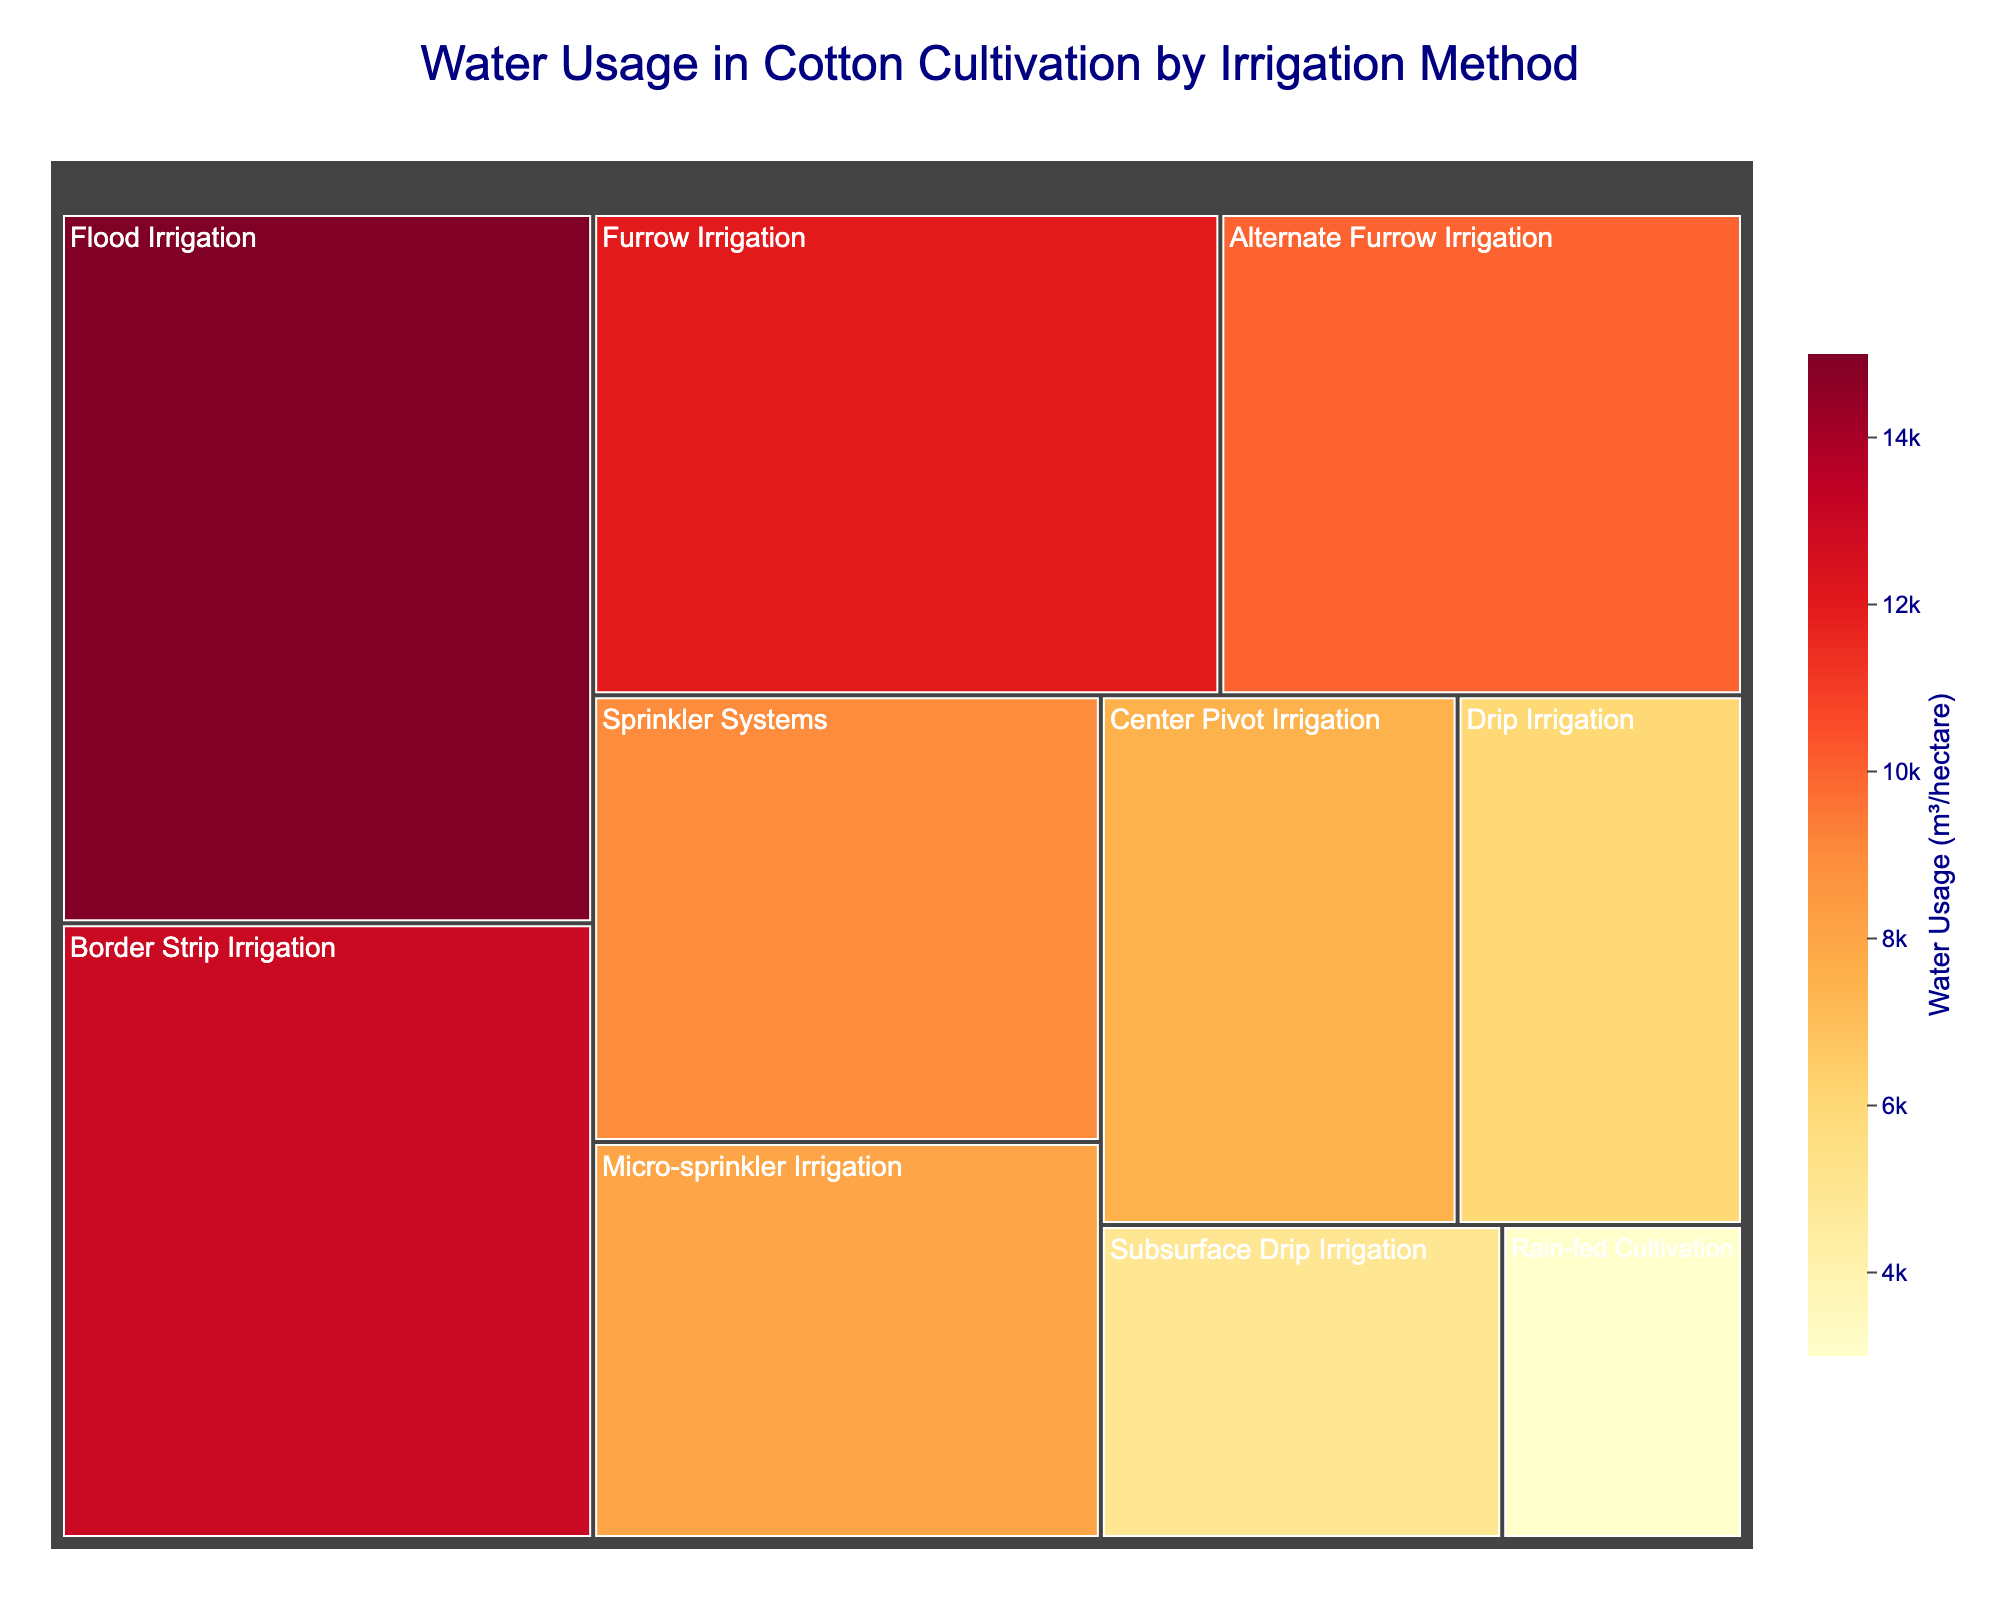Which irrigation method has the highest water usage? The figure allows us to see that the Flood Irrigation method has the largest area and darkest color, indicating the highest water usage.
Answer: Flood Irrigation What is the water usage for Drip Irrigation? By referring to the size and label of the Drip Irrigation section, which is smaller and lighter than others, the water usage is shown as 6000 m³/hectare.
Answer: 6000 m³/hectare How many irrigation methods use more than 10000 m³/hectare of water? Checking the sections with water usage values on the treemap, Flood Irrigation (15000), Furrow Irrigation (12000), and Border Strip Irrigation (13000) use more than 10000 m³/hectare.
Answer: 3 Which irrigation method uses the least amount of water? The smallest and lightest section in the treemap is Rain-fed Cultivation, indicating it uses the least water.
Answer: Rain-fed Cultivation What is the total water usage of the Subsurface Drip Irrigation and Micro-sprinkler Irrigation methods combined? Adding the water usage for Subsurface Drip Irrigation (5000 m³/hectare) and Micro-sprinkler Irrigation (8000 m³/hectare), the total is 5000 + 8000 = 13000 m³/hectare.
Answer: 13000 m³/hectare How does the water usage of Center Pivot Irrigation compare to Sprinkler Systems? Center Pivot Irrigation uses 7500 m³/hectare, whereas Sprinkler Systems use 9000 m³/hectare. So, Center Pivot Irrigation uses less water than Sprinkler Systems.
Answer: Center Pivot Irrigation uses less water Which irrigation method among Alternate Furrow Irrigation and Furrow Irrigation uses less water? According to the treemap, Alternate Furrow Irrigation uses 10000 m³/hectare, and Furrow Irrigation uses 12000 m³/hectare. Therefore, Alternate Furrow Irrigation uses less water.
Answer: Alternate Furrow Irrigation What is the average water usage of all irrigation methods listed? Summing up all water usage values: 15000 + 12000 + 9000 + 6000 + 7500 + 5000 + 3000 + 10000 + 13000 + 8000 = 88500. There are 10 methods, so the average is 88500 / 10 = 8850 m³/hectare.
Answer: 8850 m³/hectare Which color on the treemap represents the highest water usage? The treemap color scale (YlOrRd) goes from light to dark. The darkest color represents the highest water usage, found in Flood Irrigation.
Answer: Darker color 